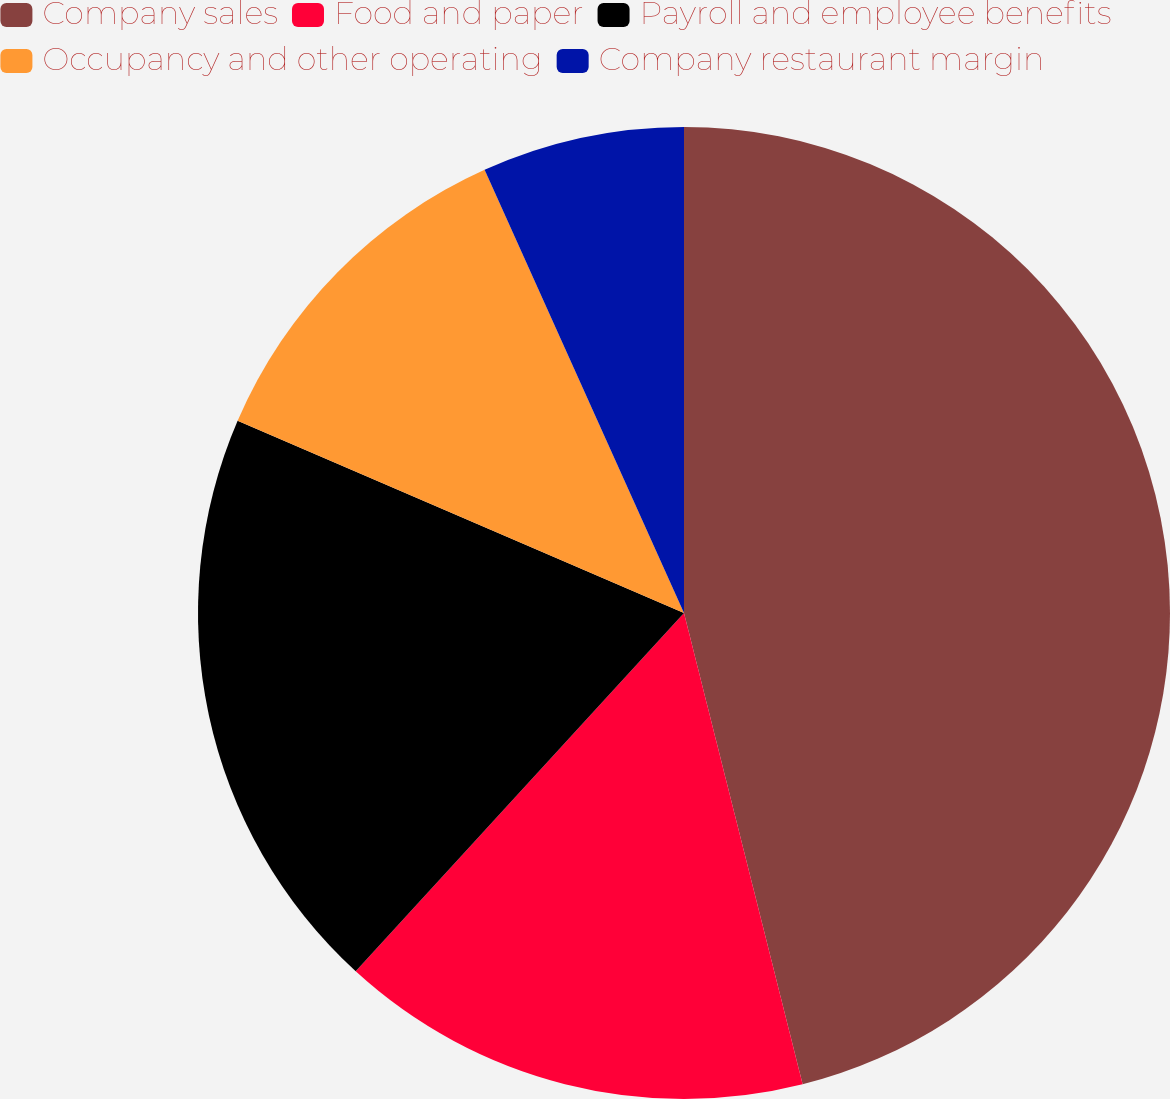<chart> <loc_0><loc_0><loc_500><loc_500><pie_chart><fcel>Company sales<fcel>Food and paper<fcel>Payroll and employee benefits<fcel>Occupancy and other operating<fcel>Company restaurant margin<nl><fcel>46.08%<fcel>15.73%<fcel>19.67%<fcel>11.8%<fcel>6.73%<nl></chart> 